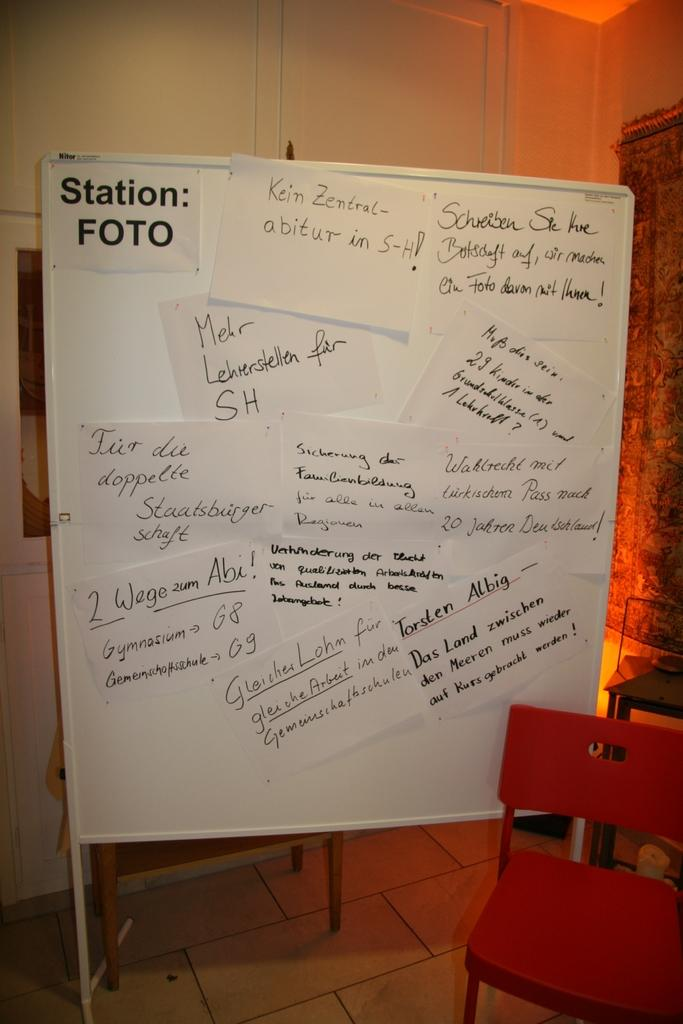What is on the board in the image? There are papers on a board in the image. What is in front of the board? There is a chair in front of the board. What can be seen in the background of the image? There is a wall in the background of the image. Is there any window treatment present in the image? Yes, there is a curtain associated with the wall. Can you tell me how many nuts the crow is holding in the image? There is no crow or nuts present in the image. What type of parent is sitting on the chair in the image? There is no parent present in the image; it only shows a chair in front of a board with papers. 